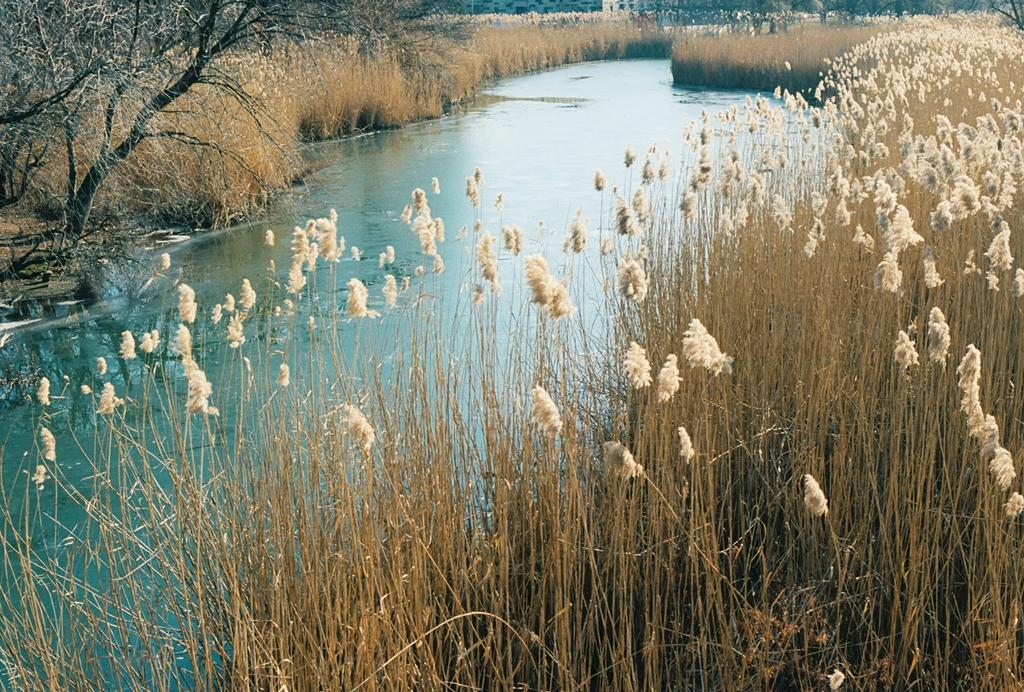What is the main feature of the image? There is a lake in the image. What type of vegetation can be seen near the lake? There is grass on either side of the lake. Are there any plants visible in the image? Yes, there is a plant in the image. Can you see any worms crawling on the watch of the governor in the image? There is no watch or governor present in the image, and therefore no worms can be observed. 